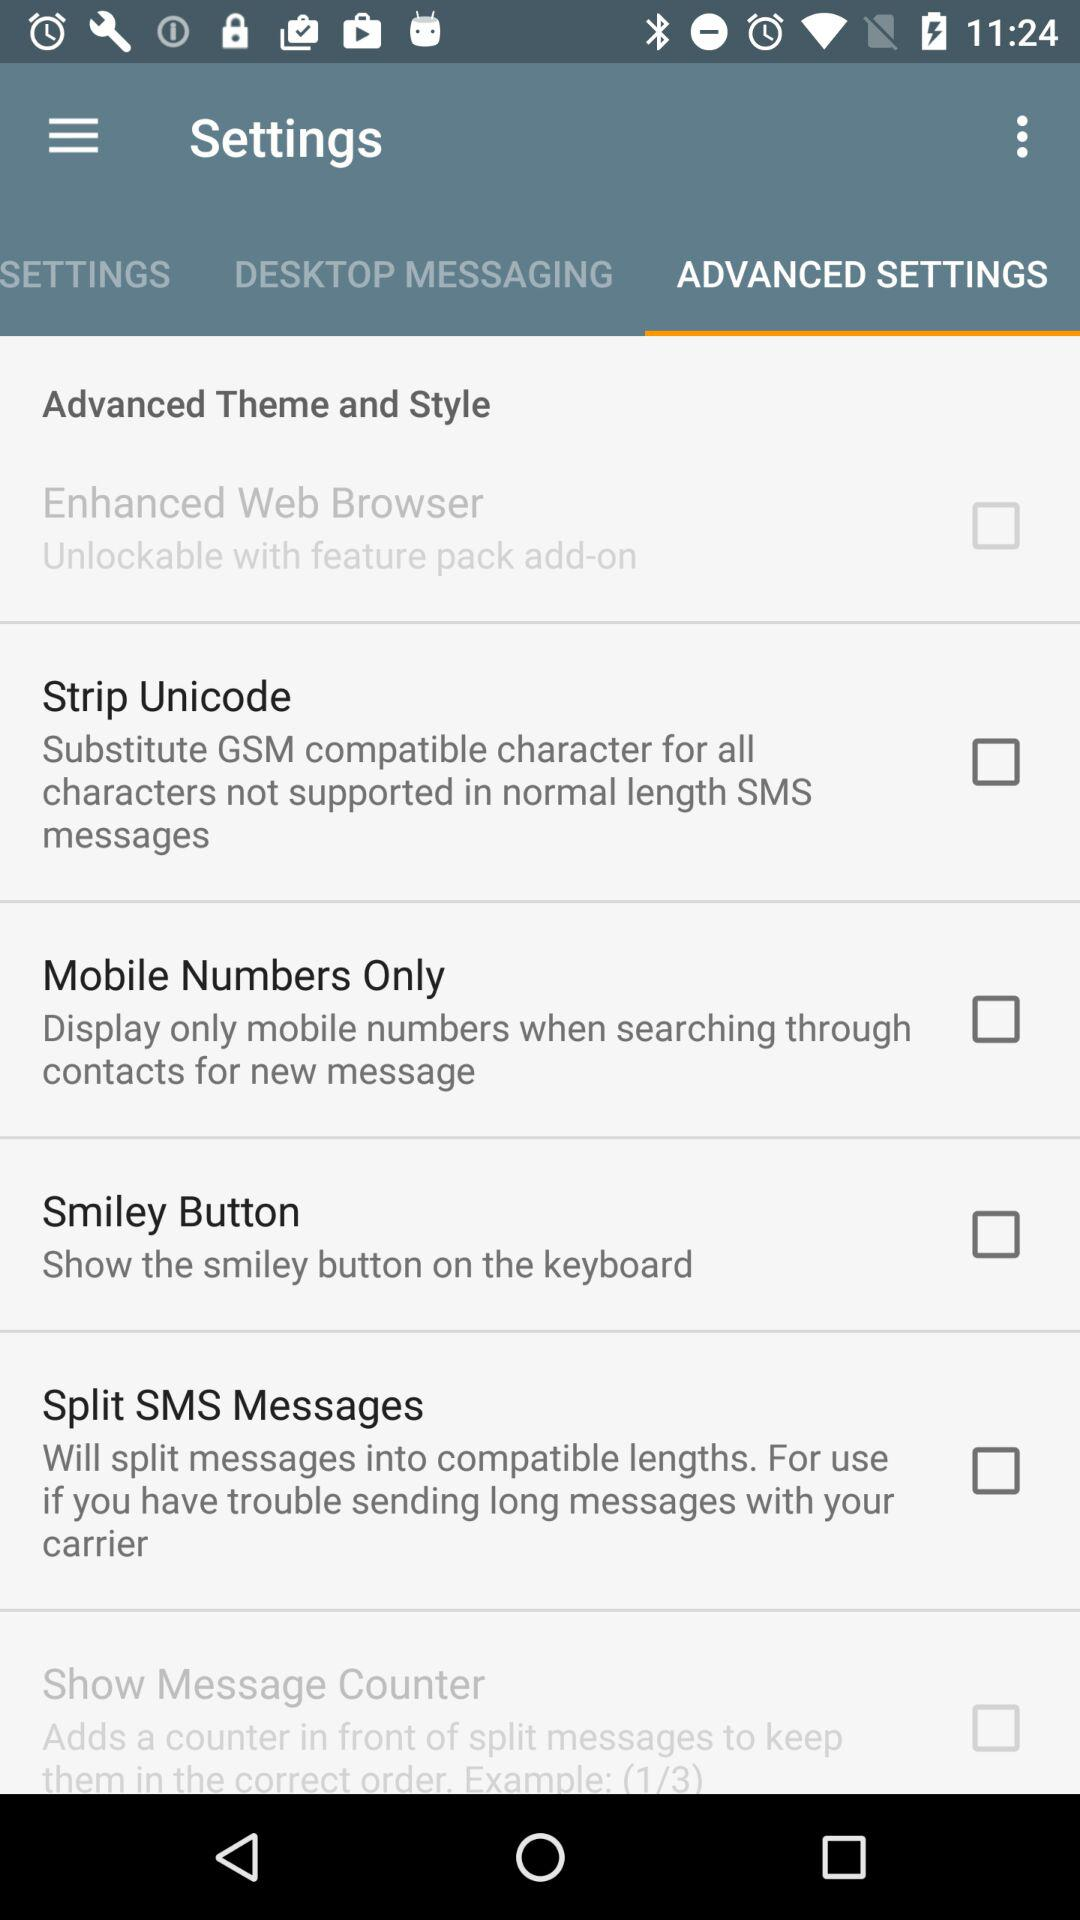What is the status of "Smiley Button"? The status is "off". 